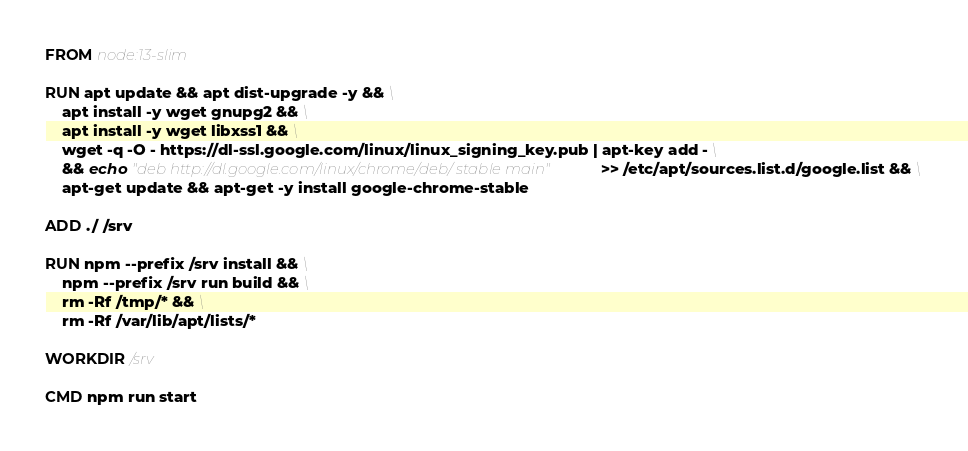Convert code to text. <code><loc_0><loc_0><loc_500><loc_500><_Dockerfile_>FROM node:13-slim

RUN apt update && apt dist-upgrade -y && \
	apt install -y wget gnupg2 && \
	apt install -y wget libxss1 && \
    wget -q -O - https://dl-ssl.google.com/linux/linux_signing_key.pub | apt-key add - \
    && echo "deb http://dl.google.com/linux/chrome/deb/ stable main" >> /etc/apt/sources.list.d/google.list && \
    apt-get update && apt-get -y install google-chrome-stable

ADD ./ /srv

RUN npm --prefix /srv install && \
    npm --prefix /srv run build && \
    rm -Rf /tmp/* && \
    rm -Rf /var/lib/apt/lists/*

WORKDIR /srv

CMD npm run start
</code> 